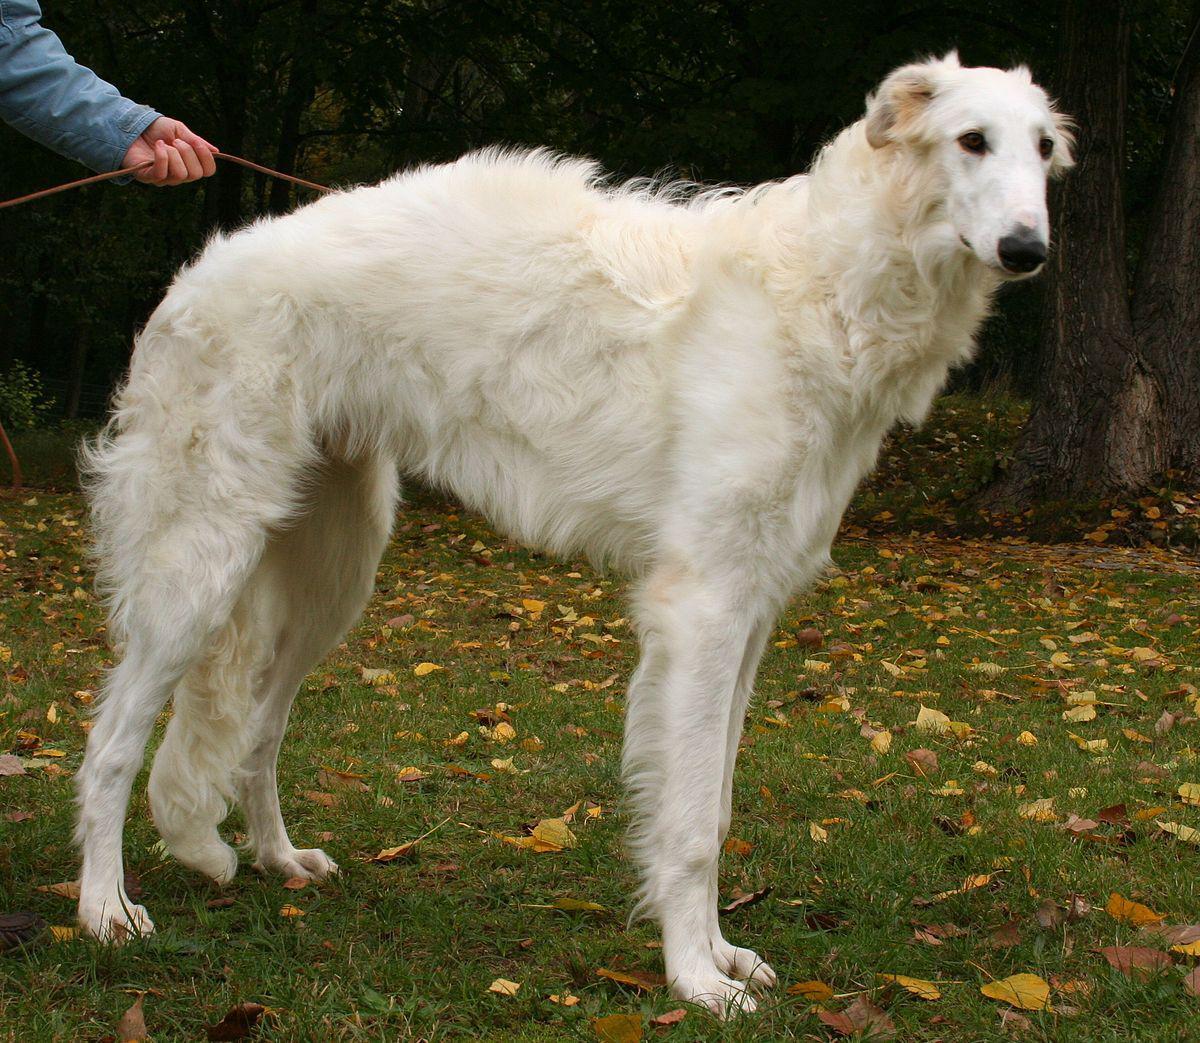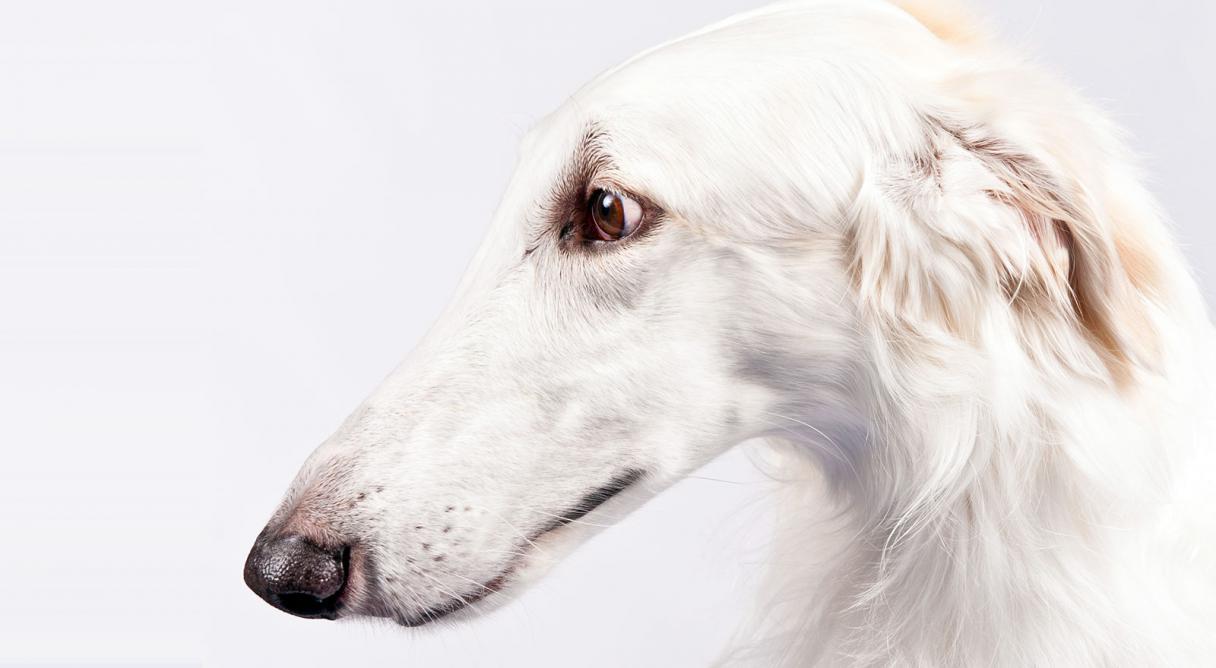The first image is the image on the left, the second image is the image on the right. Examine the images to the left and right. Is the description "An image shows a hound standing on the grassy ground." accurate? Answer yes or no. Yes. 